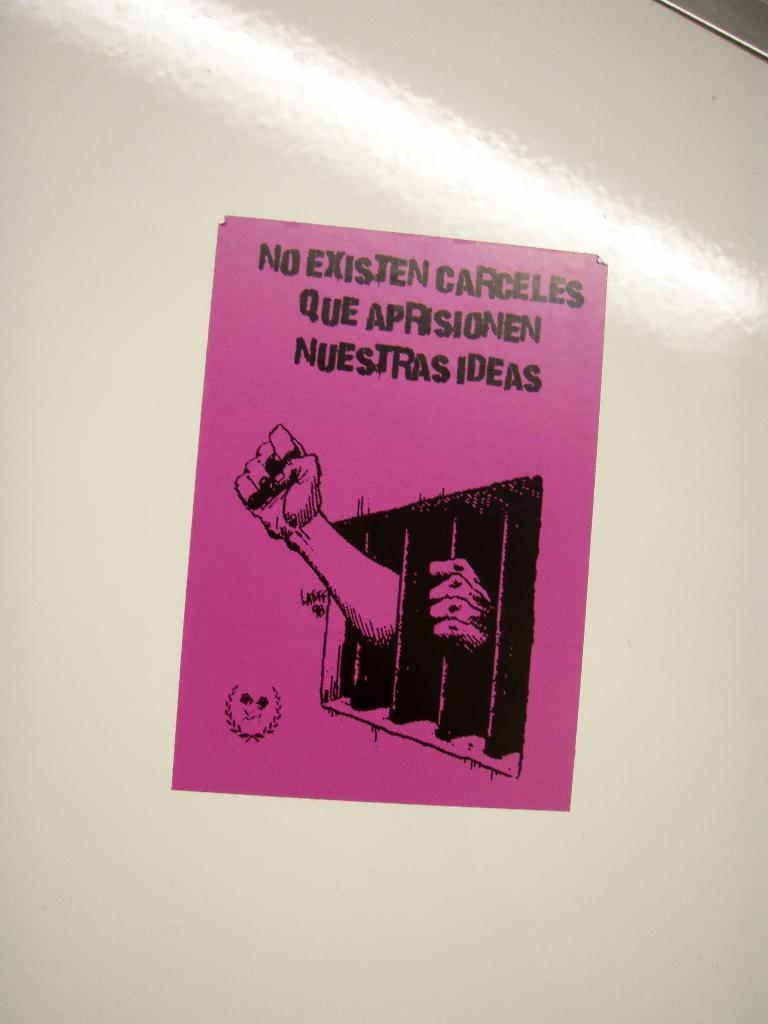<image>
Share a concise interpretation of the image provided. A flyer in Spanish fights for not imprisoning the people's ideas. 